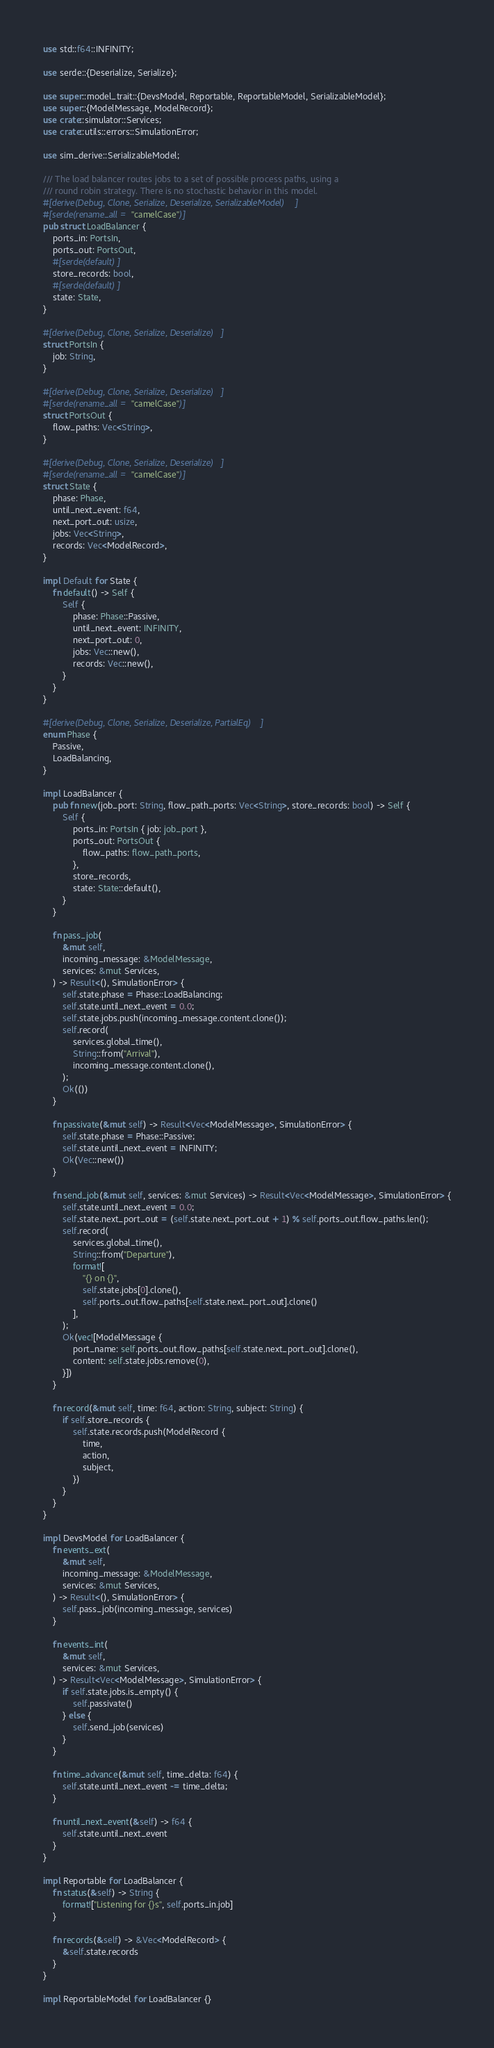<code> <loc_0><loc_0><loc_500><loc_500><_Rust_>use std::f64::INFINITY;

use serde::{Deserialize, Serialize};

use super::model_trait::{DevsModel, Reportable, ReportableModel, SerializableModel};
use super::{ModelMessage, ModelRecord};
use crate::simulator::Services;
use crate::utils::errors::SimulationError;

use sim_derive::SerializableModel;

/// The load balancer routes jobs to a set of possible process paths, using a
/// round robin strategy. There is no stochastic behavior in this model.
#[derive(Debug, Clone, Serialize, Deserialize, SerializableModel)]
#[serde(rename_all = "camelCase")]
pub struct LoadBalancer {
    ports_in: PortsIn,
    ports_out: PortsOut,
    #[serde(default)]
    store_records: bool,
    #[serde(default)]
    state: State,
}

#[derive(Debug, Clone, Serialize, Deserialize)]
struct PortsIn {
    job: String,
}

#[derive(Debug, Clone, Serialize, Deserialize)]
#[serde(rename_all = "camelCase")]
struct PortsOut {
    flow_paths: Vec<String>,
}

#[derive(Debug, Clone, Serialize, Deserialize)]
#[serde(rename_all = "camelCase")]
struct State {
    phase: Phase,
    until_next_event: f64,
    next_port_out: usize,
    jobs: Vec<String>,
    records: Vec<ModelRecord>,
}

impl Default for State {
    fn default() -> Self {
        Self {
            phase: Phase::Passive,
            until_next_event: INFINITY,
            next_port_out: 0,
            jobs: Vec::new(),
            records: Vec::new(),
        }
    }
}

#[derive(Debug, Clone, Serialize, Deserialize, PartialEq)]
enum Phase {
    Passive,
    LoadBalancing,
}

impl LoadBalancer {
    pub fn new(job_port: String, flow_path_ports: Vec<String>, store_records: bool) -> Self {
        Self {
            ports_in: PortsIn { job: job_port },
            ports_out: PortsOut {
                flow_paths: flow_path_ports,
            },
            store_records,
            state: State::default(),
        }
    }

    fn pass_job(
        &mut self,
        incoming_message: &ModelMessage,
        services: &mut Services,
    ) -> Result<(), SimulationError> {
        self.state.phase = Phase::LoadBalancing;
        self.state.until_next_event = 0.0;
        self.state.jobs.push(incoming_message.content.clone());
        self.record(
            services.global_time(),
            String::from("Arrival"),
            incoming_message.content.clone(),
        );
        Ok(())
    }

    fn passivate(&mut self) -> Result<Vec<ModelMessage>, SimulationError> {
        self.state.phase = Phase::Passive;
        self.state.until_next_event = INFINITY;
        Ok(Vec::new())
    }

    fn send_job(&mut self, services: &mut Services) -> Result<Vec<ModelMessage>, SimulationError> {
        self.state.until_next_event = 0.0;
        self.state.next_port_out = (self.state.next_port_out + 1) % self.ports_out.flow_paths.len();
        self.record(
            services.global_time(),
            String::from("Departure"),
            format![
                "{} on {}",
                self.state.jobs[0].clone(),
                self.ports_out.flow_paths[self.state.next_port_out].clone()
            ],
        );
        Ok(vec![ModelMessage {
            port_name: self.ports_out.flow_paths[self.state.next_port_out].clone(),
            content: self.state.jobs.remove(0),
        }])
    }

    fn record(&mut self, time: f64, action: String, subject: String) {
        if self.store_records {
            self.state.records.push(ModelRecord {
                time,
                action,
                subject,
            })
        }
    }
}

impl DevsModel for LoadBalancer {
    fn events_ext(
        &mut self,
        incoming_message: &ModelMessage,
        services: &mut Services,
    ) -> Result<(), SimulationError> {
        self.pass_job(incoming_message, services)
    }

    fn events_int(
        &mut self,
        services: &mut Services,
    ) -> Result<Vec<ModelMessage>, SimulationError> {
        if self.state.jobs.is_empty() {
            self.passivate()
        } else {
            self.send_job(services)
        }
    }

    fn time_advance(&mut self, time_delta: f64) {
        self.state.until_next_event -= time_delta;
    }

    fn until_next_event(&self) -> f64 {
        self.state.until_next_event
    }
}

impl Reportable for LoadBalancer {
    fn status(&self) -> String {
        format!["Listening for {}s", self.ports_in.job]
    }

    fn records(&self) -> &Vec<ModelRecord> {
        &self.state.records
    }
}

impl ReportableModel for LoadBalancer {}
</code> 